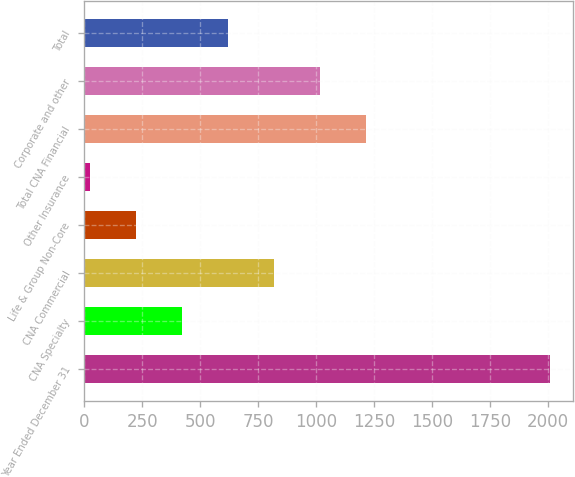Convert chart to OTSL. <chart><loc_0><loc_0><loc_500><loc_500><bar_chart><fcel>Year Ended December 31<fcel>CNA Specialty<fcel>CNA Commercial<fcel>Life & Group Non-Core<fcel>Other Insurance<fcel>Total CNA Financial<fcel>Corporate and other<fcel>Total<nl><fcel>2007<fcel>420.6<fcel>817.2<fcel>222.3<fcel>24<fcel>1213.8<fcel>1015.5<fcel>618.9<nl></chart> 